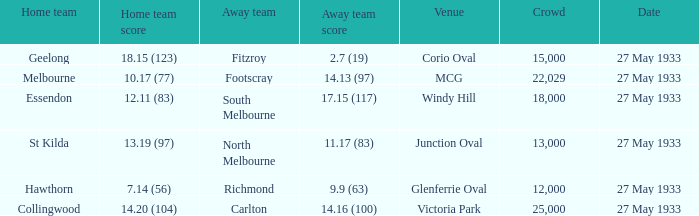During st kilda's home game, what was the number of people in the crowd? 13000.0. Parse the full table. {'header': ['Home team', 'Home team score', 'Away team', 'Away team score', 'Venue', 'Crowd', 'Date'], 'rows': [['Geelong', '18.15 (123)', 'Fitzroy', '2.7 (19)', 'Corio Oval', '15,000', '27 May 1933'], ['Melbourne', '10.17 (77)', 'Footscray', '14.13 (97)', 'MCG', '22,029', '27 May 1933'], ['Essendon', '12.11 (83)', 'South Melbourne', '17.15 (117)', 'Windy Hill', '18,000', '27 May 1933'], ['St Kilda', '13.19 (97)', 'North Melbourne', '11.17 (83)', 'Junction Oval', '13,000', '27 May 1933'], ['Hawthorn', '7.14 (56)', 'Richmond', '9.9 (63)', 'Glenferrie Oval', '12,000', '27 May 1933'], ['Collingwood', '14.20 (104)', 'Carlton', '14.16 (100)', 'Victoria Park', '25,000', '27 May 1933']]} 